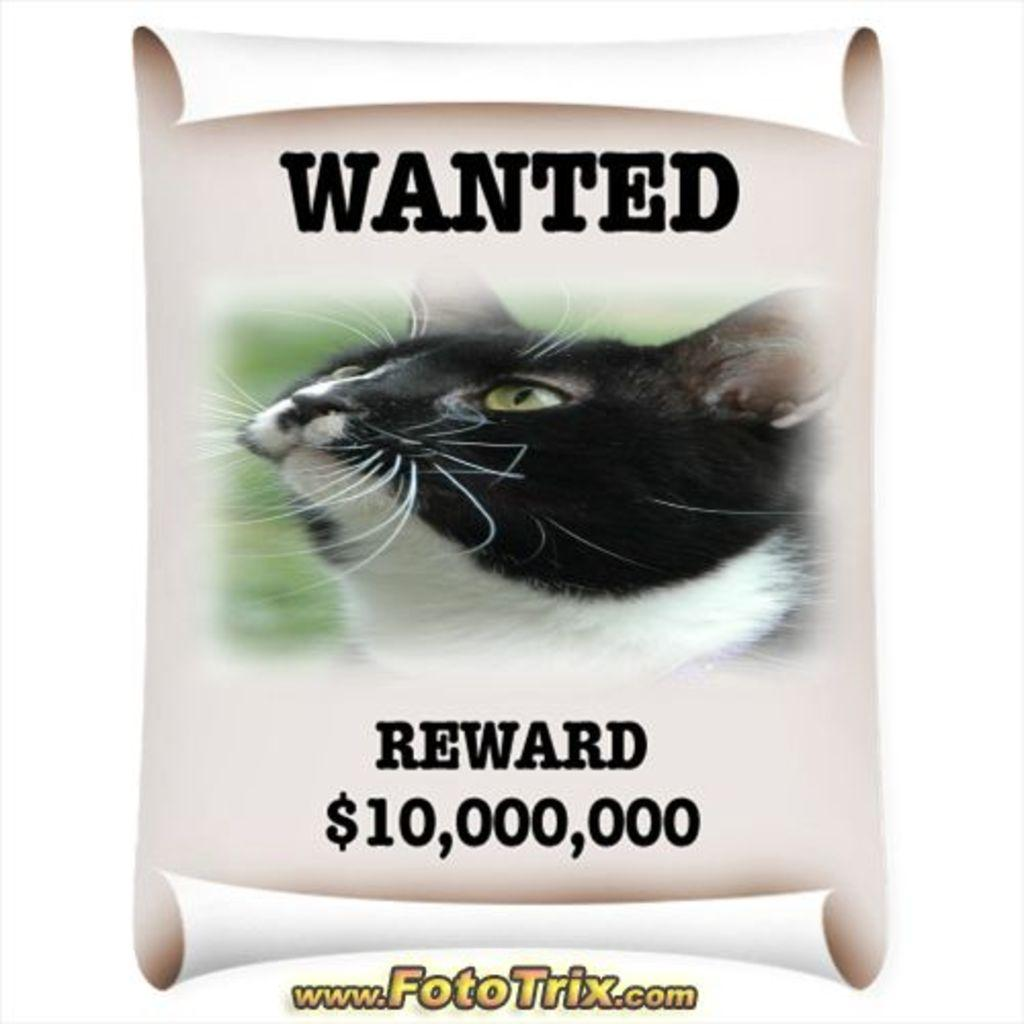What is featured on the poster in the image? The poster contains a picture of a cat. What else can be seen on the poster besides the picture of the cat? There is text on the poster. Where is the text located on the poster? There is text at the bottom of the poster. What type of store is depicted in the image? There is no store depicted in the image; it features a poster with a picture of a cat and text. How much tax is being charged for the cat in the image? There is no indication of tax or any financial transaction in the image; it simply shows a poster with a picture of a cat and text. 